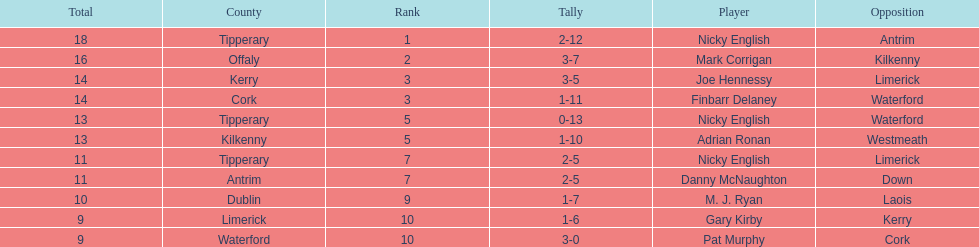What is the first name on the list? Nicky English. 